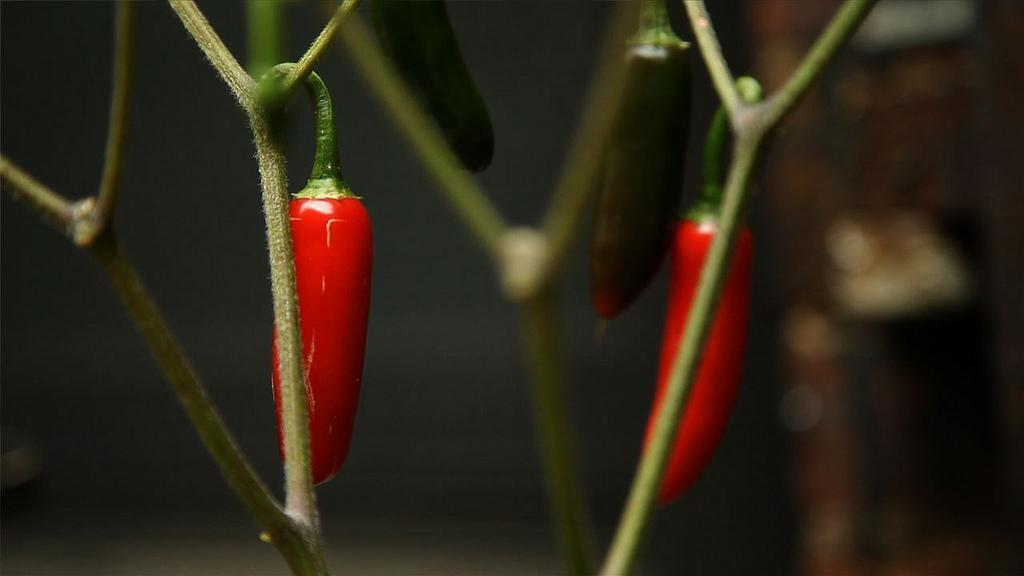What type of food is visible in the image? The image contains red chilies. How are the chilies arranged in the image? The chilies are hanged on the stems of a plant. What color are the stems of the plant? The stems are green in color. What type of lizards can be seen crawling on the chilies in the image? There are no lizards present in the image; it only features red chilies hanging on green stems. 